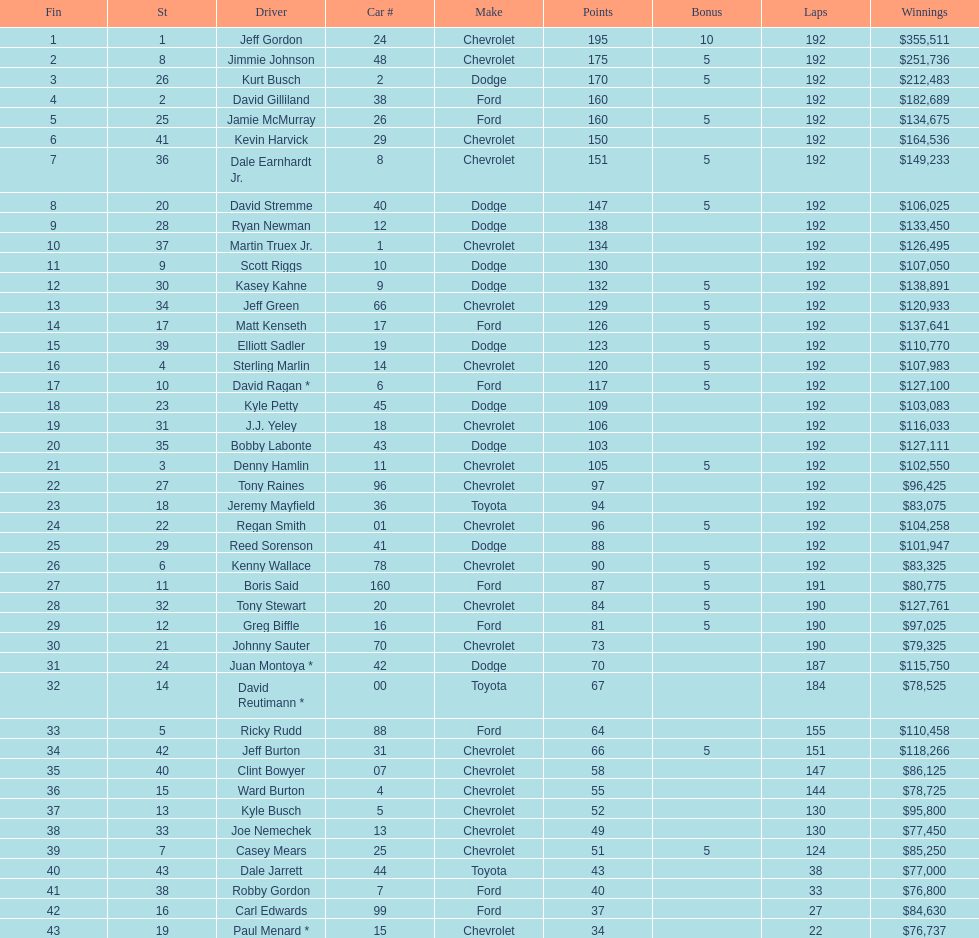Who received the highest bonus points? Jeff Gordon. 